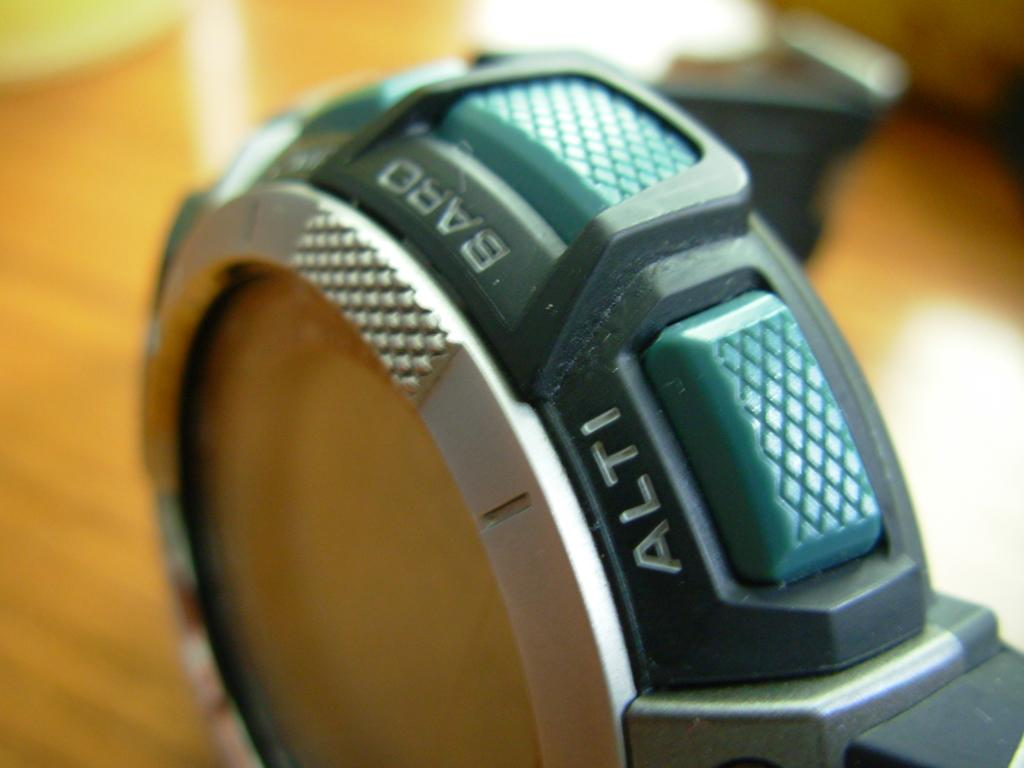What object is the main focus of the image? There is a watch in the image. Can you describe the background of the image? The background of the image is blurred. Is there any smoke coming from the watch in the image? No, there is no smoke present in the image. How many cows can be seen grazing in the background of the image? There are no cows visible in the image, as the background is blurred. 